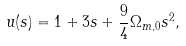Convert formula to latex. <formula><loc_0><loc_0><loc_500><loc_500>u ( s ) = 1 + 3 s + \frac { 9 } { 4 } \Omega _ { m , 0 } s ^ { 2 } ,</formula> 